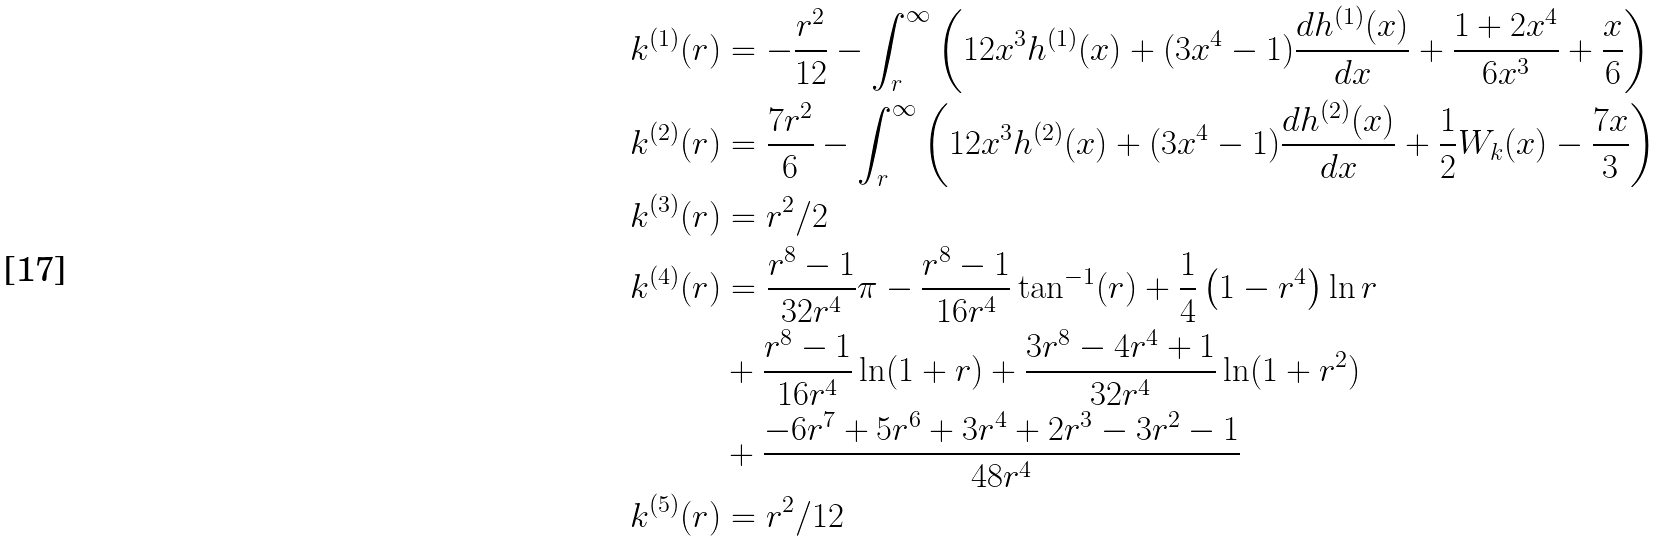<formula> <loc_0><loc_0><loc_500><loc_500>k ^ { ( 1 ) } ( r ) & = - \frac { r ^ { 2 } } { 1 2 } - \int _ { r } ^ { \infty } \left ( 1 2 x ^ { 3 } h ^ { ( 1 ) } ( x ) + ( 3 x ^ { 4 } - 1 ) \frac { d h ^ { ( 1 ) } ( x ) } { d x } + \frac { 1 + 2 x ^ { 4 } } { 6 x ^ { 3 } } + \frac { x } { 6 } \right ) \\ k ^ { ( 2 ) } ( r ) & = \frac { 7 r ^ { 2 } } { 6 } - \int _ { r } ^ { \infty } \left ( 1 2 x ^ { 3 } h ^ { ( 2 ) } ( x ) + ( 3 x ^ { 4 } - 1 ) \frac { d h ^ { ( 2 ) } ( x ) } { d x } + \frac { 1 } { 2 } W _ { k } ( x ) - \frac { 7 x } { 3 } \right ) \\ k ^ { ( 3 ) } ( r ) & = r ^ { 2 } / 2 \\ k ^ { ( 4 ) } ( r ) & = \frac { r ^ { 8 } - 1 } { 3 2 r ^ { 4 } } \pi - \frac { r ^ { 8 } - 1 } { 1 6 r ^ { 4 } } \tan ^ { - 1 } ( r ) + \frac { 1 } { 4 } \left ( 1 - r ^ { 4 } \right ) \ln r \\ & + \frac { r ^ { 8 } - 1 } { 1 6 r ^ { 4 } } \ln ( 1 + r ) + \frac { 3 r ^ { 8 } - 4 r ^ { 4 } + 1 } { 3 2 r ^ { 4 } } \ln ( 1 + r ^ { 2 } ) \\ & + \frac { - 6 r ^ { 7 } + 5 r ^ { 6 } + 3 r ^ { 4 } + 2 r ^ { 3 } - 3 r ^ { 2 } - 1 } { 4 8 r ^ { 4 } } \\ k ^ { ( 5 ) } ( r ) & = r ^ { 2 } / 1 2 \\</formula> 